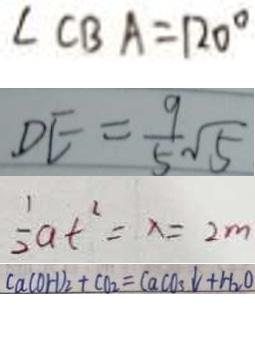Convert formula to latex. <formula><loc_0><loc_0><loc_500><loc_500>\angle C B A = 1 2 0 ^ { \circ } 
 D E = \frac { 9 } { 5 } \sqrt { 5 } 
 \frac { 1 } { 2 } a t ^ { 2 } = x = 2 m 
 C a ( O H ) _ { 2 } + C O _ { 2 } = C a C O _ { 3 } \downarrow + H _ { 2 } O</formula> 